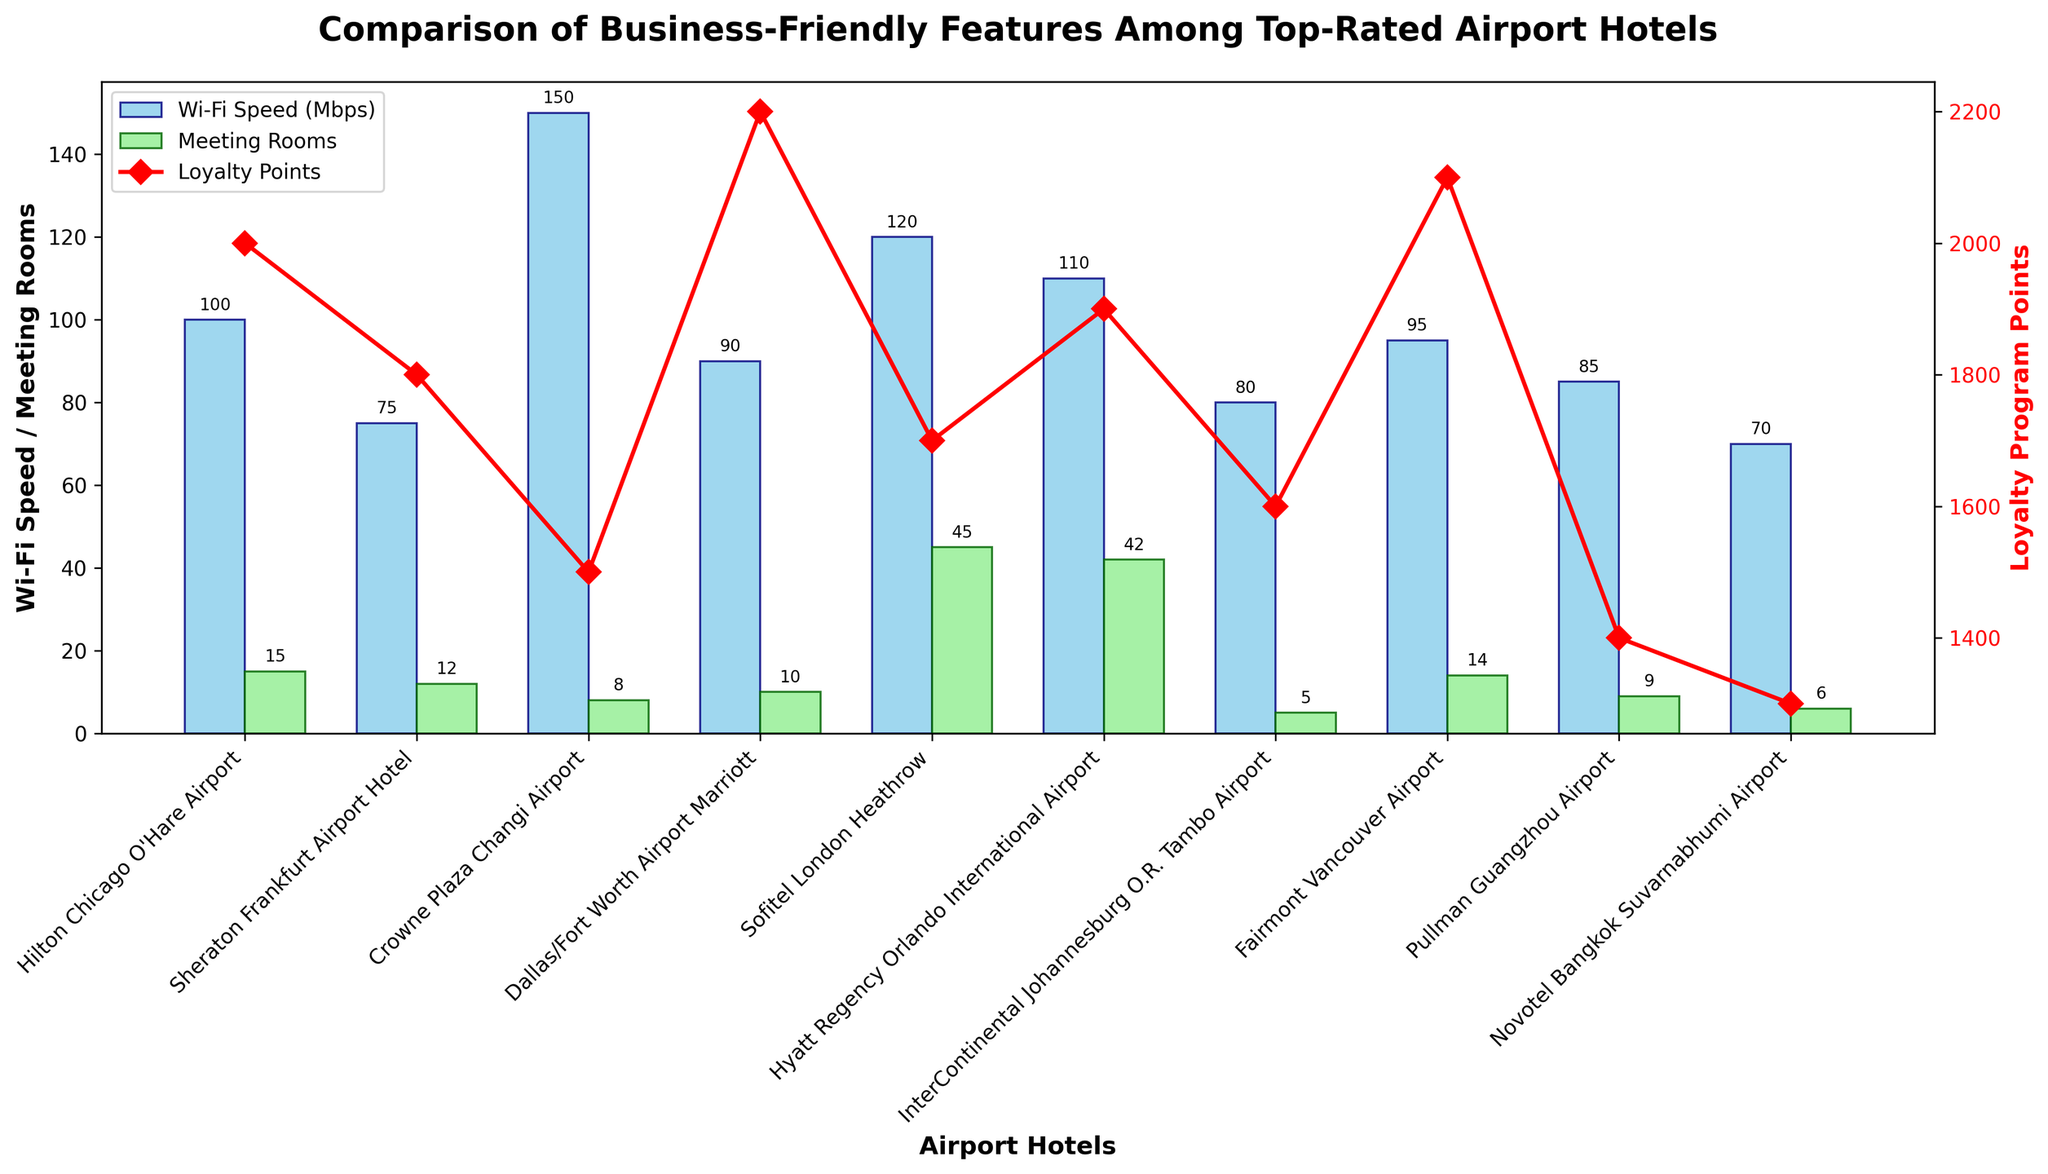Which hotel offers the fastest free Wi-Fi speed? By looking at the height of the bars for Wi-Fi speed on the bar chart, we see that the Crowne Plaza Changi Airport has the highest bar.
Answer: Crowne Plaza Changi Airport Which two hotels have the most meeting rooms? By comparing the heights of the bars representing meeting rooms, we notice that Sofitel London Heathrow and Hyatt Regency Orlando International Airport have the tallest bars.
Answer: Sofitel London Heathrow, Hyatt Regency Orlando International Airport Which hotel provides the most loyalty program points per stay? The red line representing loyalty program points peaks at the bar corresponding to Dallas/Fort Worth Airport Marriott.
Answer: Dallas/Fort Worth Airport Marriott Does any hotel offer both high Wi-Fi speed (above 100 Mbps) and many meeting rooms (more than 10)? By cross-checking the hotels with Wi-Fi speeds above 100 Mbps and comparing them with those having more than 10 meeting rooms, we find that Hyatt Regency Orlando International Airport meets both criteria.
Answer: Hyatt Regency Orlando International Airport Compare the shuttle service frequency for the Hilton Chicago O'Hare Airport and the Dallas/Fort Worth Airport Marriott. Which one is higher? By looking at the provided data, the Hilton Chicago O'Hare Airport has a shuttle service frequency of 4 per hour, while Dallas/Fort Worth Airport Marriott has 2. Thus, Hilton has a higher frequency.
Answer: Hilton Chicago O'Hare Airport What is the average Wi-Fi speed of all the hotels combined? Sum all the Wi-Fi speeds: 100 + 75 + 150 + 90 + 120 + 110 + 80 + 95 + 85 + 70 = 975 Mbps. Divide by the number of hotels (10): 975/10 = 97.5 Mbps.
Answer: 97.5 Mbps How does the number of meeting rooms at InterContinental Johannesburg compare to the average? InterContinental Johannesburg has 5 meeting rooms. The total number of rooms is 15 + 12 + 8 + 10 + 45 + 42 + 5 + 14 + 9 + 6 = 166. The average is 166/10 = 16.6. Comparing 5 to 16.6 shows it’s below average.
Answer: Below average Which hotel has the smallest difference between its Wi-Fi speed and the number of its meeting rooms? Subtract the number of meeting rooms from Wi-Fi speeds for each hotel and compare the differences: 
- Hilton Chicago: 100 - 15 = 85 
- Sheraton Frankfurt: 75 - 12 = 63 
- Crowne Plaza: 150 - 8 = 142 
- Dallas/Fort Worth: 90 - 10 = 80 
- Sofitel London Heathrow: 120 - 45 = 75 
- Hyatt Regency Orlando: 110 - 42 = 68 
- InterContinental Johannesburg: 80 - 5 = 75 
- Fairmont Vancouver: 95 - 14 = 81 
- Pullman Guangzhou: 85 - 9 = 76 
- Novotel Bangkok: 70 - 6 = 64. 
The smallest difference is 63 for Sheraton Frankfurt.
Answer: Sheraton Frankfurt Airport Hotel Does any hotel have all five features: 24/7 room service, express check-in/out, a business center with at least 20 hours a day, Wi-Fi speed of at least 100 Mbps, and a shuttle service frequency of at least 3 per hour? By matching the feature criteria, Hilton Chicago O’Hare Airport offers all, with a 24-hour business center, 100 Mbps Wi-Fi, and a shuttle service frequency of 4 per hour.
Answer: Hilton Chicago O'Hare Airport 